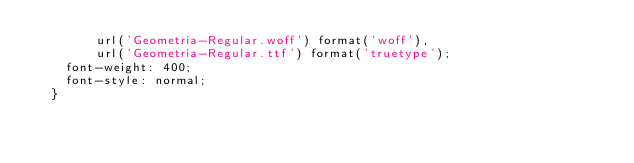<code> <loc_0><loc_0><loc_500><loc_500><_CSS_>        url('Geometria-Regular.woff') format('woff'),
        url('Geometria-Regular.ttf') format('truetype');
    font-weight: 400;
    font-style: normal;
  }</code> 